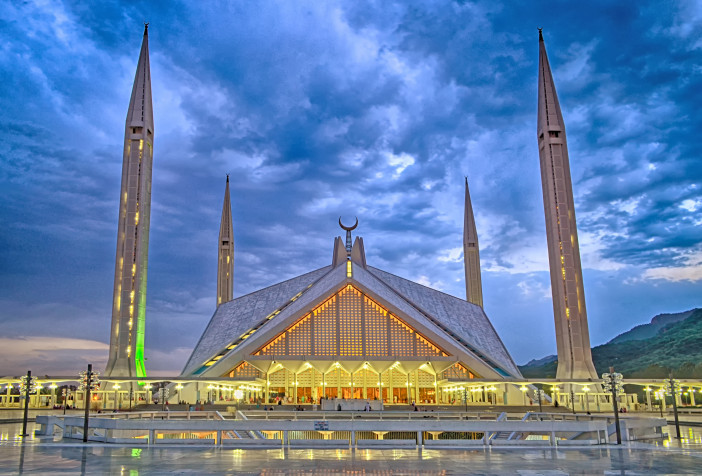What do you see happening in this image? The image depicts the stunning Faisal Mosque in Islamabad, captured during an enchanting twilight. This modernist marvel is renowned for its unique design, featuring four soaring minarets and a large triangular prayer hall. In the image, the mosque's white structure contrasts dramatically against a vibrant twilight sky, filled with deep blue hues and streaks of clouds, highlighting the mosque’s grand silhouette. The strategic lighting accentuates its geometric beauty and serene ambiance, inviting reflection on its design which merges contemporary lines with traditional Islamic architecture, creating a captivating landmark that not only serves as a place of worship but also as a symbol of national pride. 